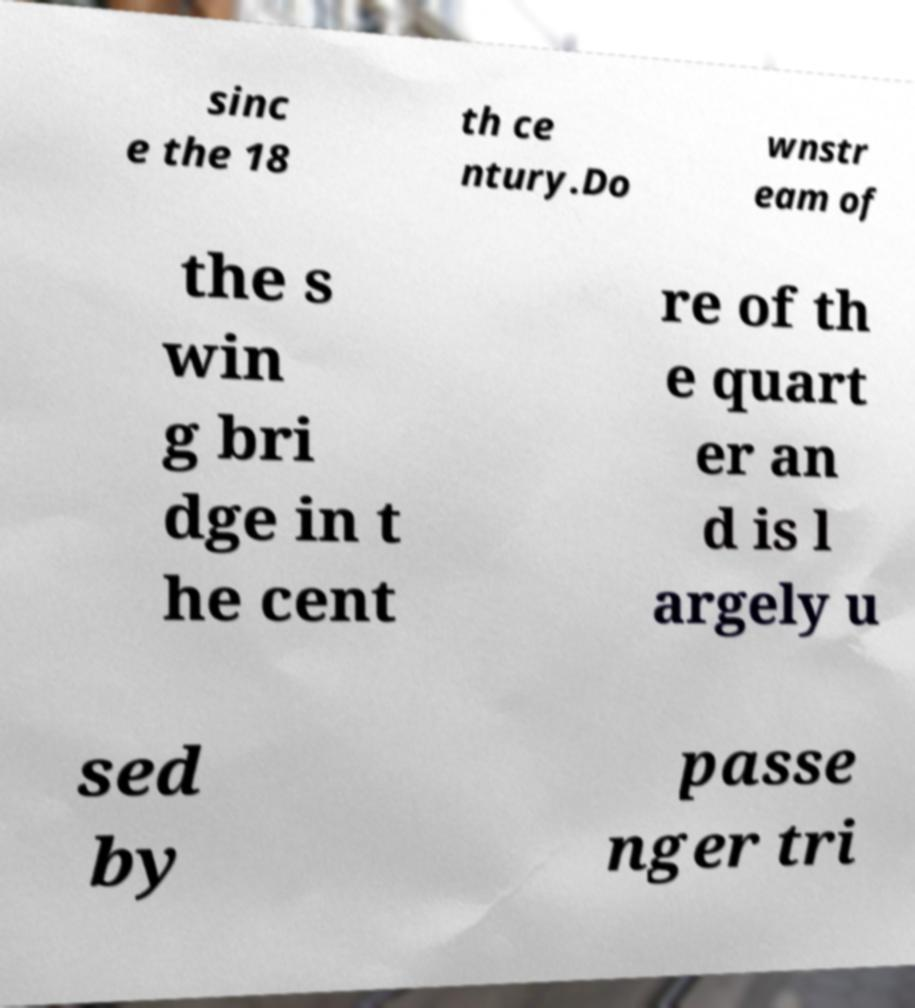Can you accurately transcribe the text from the provided image for me? sinc e the 18 th ce ntury.Do wnstr eam of the s win g bri dge in t he cent re of th e quart er an d is l argely u sed by passe nger tri 